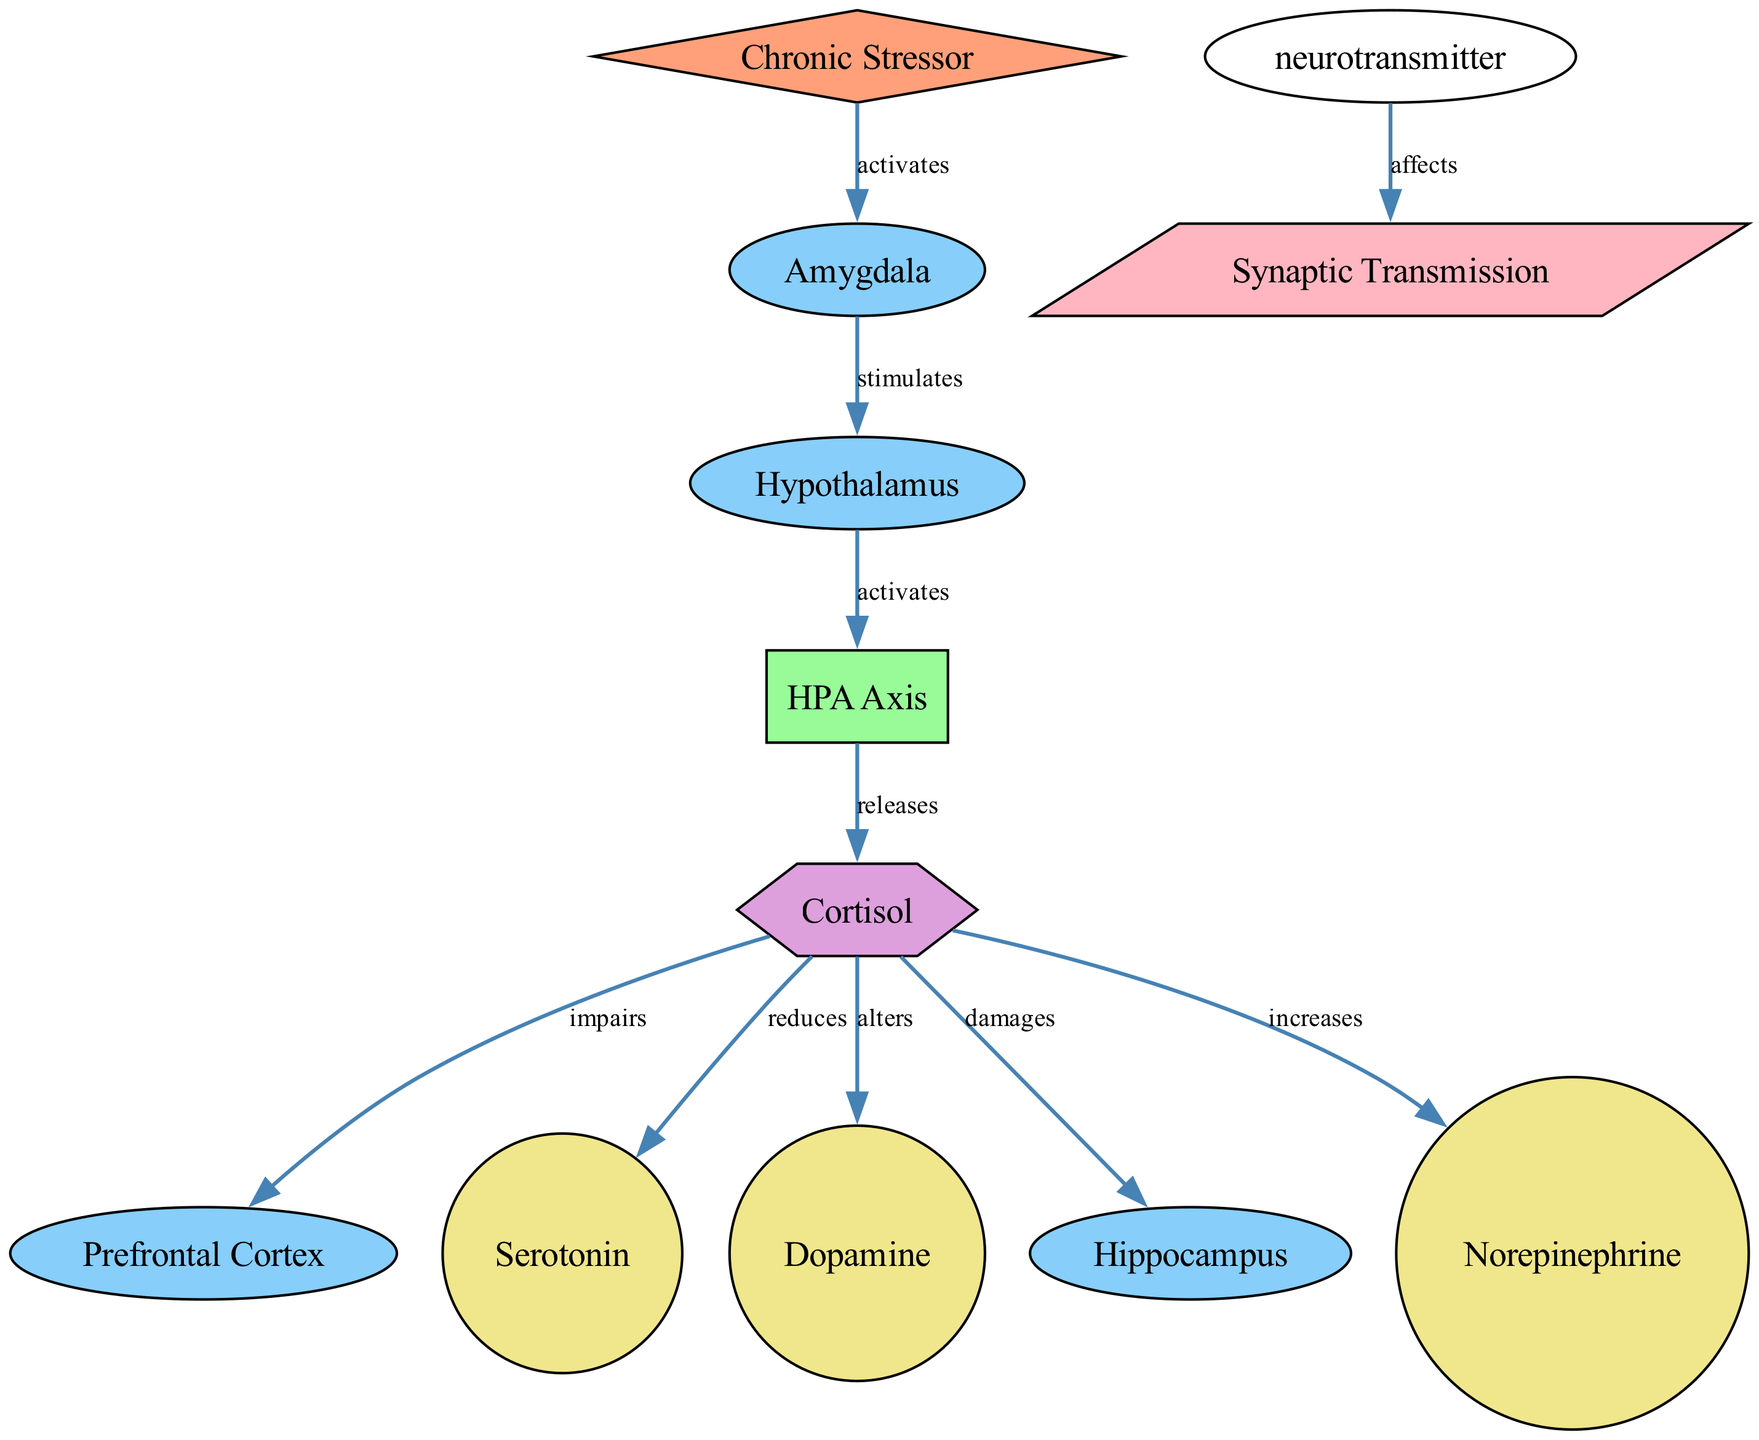What are the main brain regions involved in this diagram? The diagram includes three brain regions: the amygdala, hypothalamus, and prefrontal cortex. These are explicitly labeled as "brain_region" in the nodes data.
Answer: amygdala, hypothalamus, prefrontal cortex How does cortisol affect serotonin levels according to the diagram? The diagram shows a direct edge from cortisol to serotonin with the label "reduces," indicating that cortisol decreases serotonin levels.
Answer: reduces What triggers the activation of the hypothalamus in this context? The diagram indicates that a chronic stressor activates the amygdala, which in turn stimulates the hypothalamus. This relationship flows from the chronic stressor to the amygdala and then to the hypothalamus.
Answer: chronic stressor How many neurotransmitters are represented in the diagram? The diagram has three neurotransmitters present: serotonin, dopamine, and norepinephrine. Count the nodes of type “neurotransmitter” to arrive at this answer.
Answer: three What is the effect of cortisol on the prefrontal cortex? The diagram labels the edge from cortisol to the prefrontal cortex as "impairs," indicating that cortisol negatively affects the functioning of this brain region.
Answer: impairs Which neurotransmitter is increased by cortisol? The diagram illustrates an edge leading from cortisol to norepinephrine labeled "increases," showing that cortisol elevates the level of norepinephrine.
Answer: norepinephrine What is the role of the HPA axis in this process? The diagram defines the HPA axis as a system that is activated by the hypothalamus in response to chronic stressors, suggesting it plays a crucial role in the stress response.
Answer: activates How does the process of synaptic transmission relate to neurotransmitters? The diagram shows an edge from neurotransmitter to synaptic transmission, implying that neurotransmitters affect synaptic transmission processes in the nervous system.
Answer: affects What is the relationship between cortisol and the hippocampus? The diagram states that cortisol "damages" the hippocampus, indicating a detrimental effect of cortisol on this brain region.
Answer: damages 